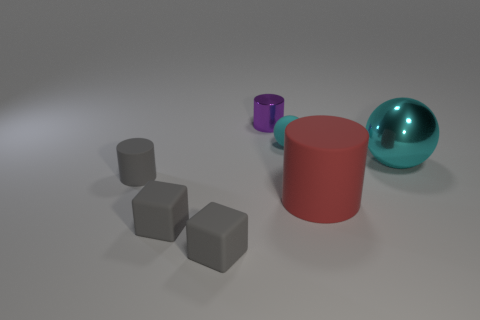Subtract all gray matte cylinders. How many cylinders are left? 2 Add 1 small yellow metal objects. How many objects exist? 8 Subtract all blocks. How many objects are left? 5 Subtract all blue cylinders. Subtract all red blocks. How many cylinders are left? 3 Add 3 things. How many things are left? 10 Add 4 big cyan things. How many big cyan things exist? 5 Subtract 0 blue spheres. How many objects are left? 7 Subtract all blocks. Subtract all large metal spheres. How many objects are left? 4 